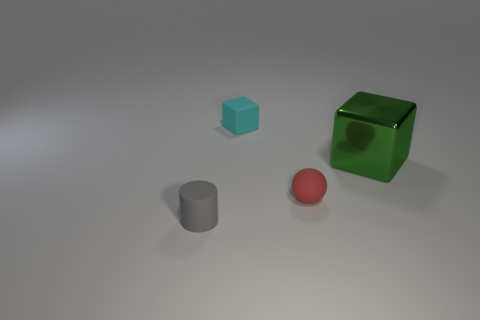Is there any other thing that has the same size as the green shiny cube?
Your answer should be very brief. No. There is a block to the right of the small red sphere; are there any small gray rubber cylinders in front of it?
Offer a very short reply. Yes. What number of green objects are the same size as the cylinder?
Keep it short and to the point. 0. There is a tiny rubber object that is in front of the tiny object to the right of the cyan rubber object; how many tiny red rubber balls are to the left of it?
Make the answer very short. 0. What number of objects are in front of the tiny cyan matte object and behind the rubber cylinder?
Your answer should be compact. 2. What number of rubber objects are either brown spheres or tiny red spheres?
Keep it short and to the point. 1. The thing that is right of the tiny thing that is to the right of the block behind the large thing is made of what material?
Offer a very short reply. Metal. What is the material of the small object that is left of the matte thing that is behind the big metal object?
Give a very brief answer. Rubber. There is a cube that is on the left side of the tiny sphere; is its size the same as the object that is to the left of the cyan cube?
Provide a succinct answer. Yes. Is there any other thing that has the same material as the big green cube?
Make the answer very short. No. 